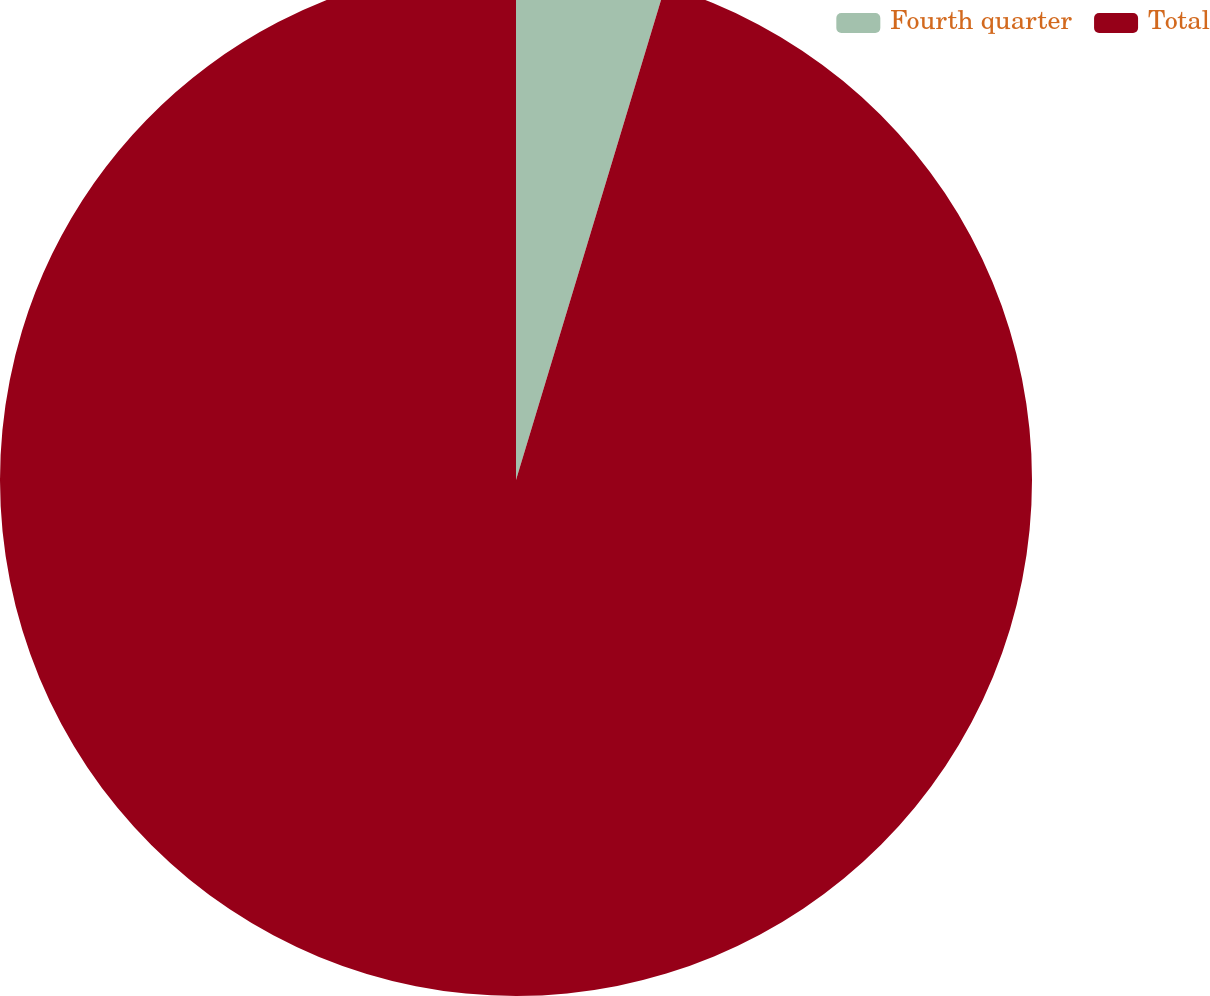Convert chart. <chart><loc_0><loc_0><loc_500><loc_500><pie_chart><fcel>Fourth quarter<fcel>Total<nl><fcel>4.67%<fcel>95.33%<nl></chart> 